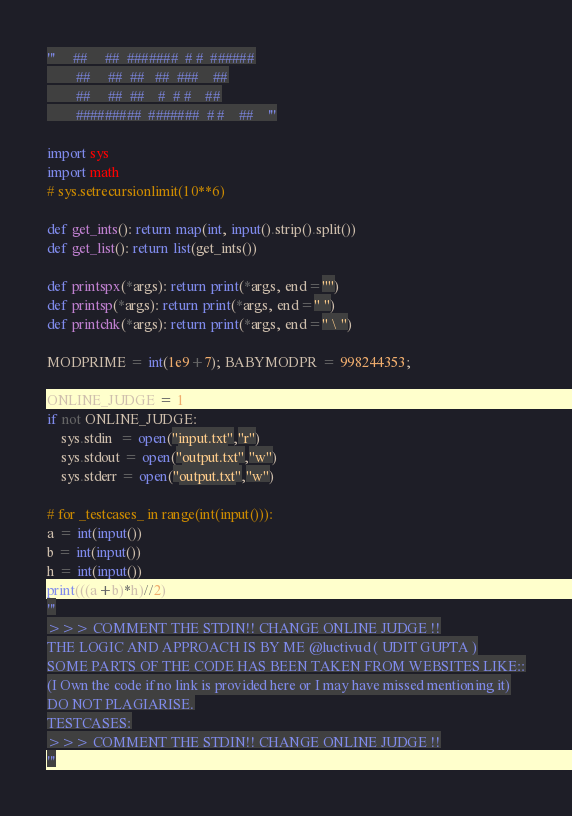Convert code to text. <code><loc_0><loc_0><loc_500><loc_500><_Python_>'''     ##     ##  #######  # #  ######
        ##     ##  ##   ##  ###    ##
        ##     ##  ##    #  # #    ##
        #########  #######  # #    ##    '''

import sys
import math
# sys.setrecursionlimit(10**6)

def get_ints(): return map(int, input().strip().split())
def get_list(): return list(get_ints())

def printspx(*args): return print(*args, end="")
def printsp(*args): return print(*args, end=" ")
def printchk(*args): return print(*args, end=" \ ")

MODPRIME = int(1e9+7); BABYMODPR = 998244353;

ONLINE_JUDGE = 1
if not ONLINE_JUDGE:
    sys.stdin  = open("input.txt","r")
    sys.stdout = open("output.txt","w")
    sys.stderr = open("output.txt","w")

# for _testcases_ in range(int(input())):
a = int(input())
b = int(input())
h = int(input())
print(((a+b)*h)//2)
'''
>>> COMMENT THE STDIN!! CHANGE ONLINE JUDGE !!
THE LOGIC AND APPROACH IS BY ME @luctivud ( UDIT GUPTA )
SOME PARTS OF THE CODE HAS BEEN TAKEN FROM WEBSITES LIKE::
(I Own the code if no link is provided here or I may have missed mentioning it)
DO NOT PLAGIARISE.
TESTCASES:
>>> COMMENT THE STDIN!! CHANGE ONLINE JUDGE !!
'''</code> 